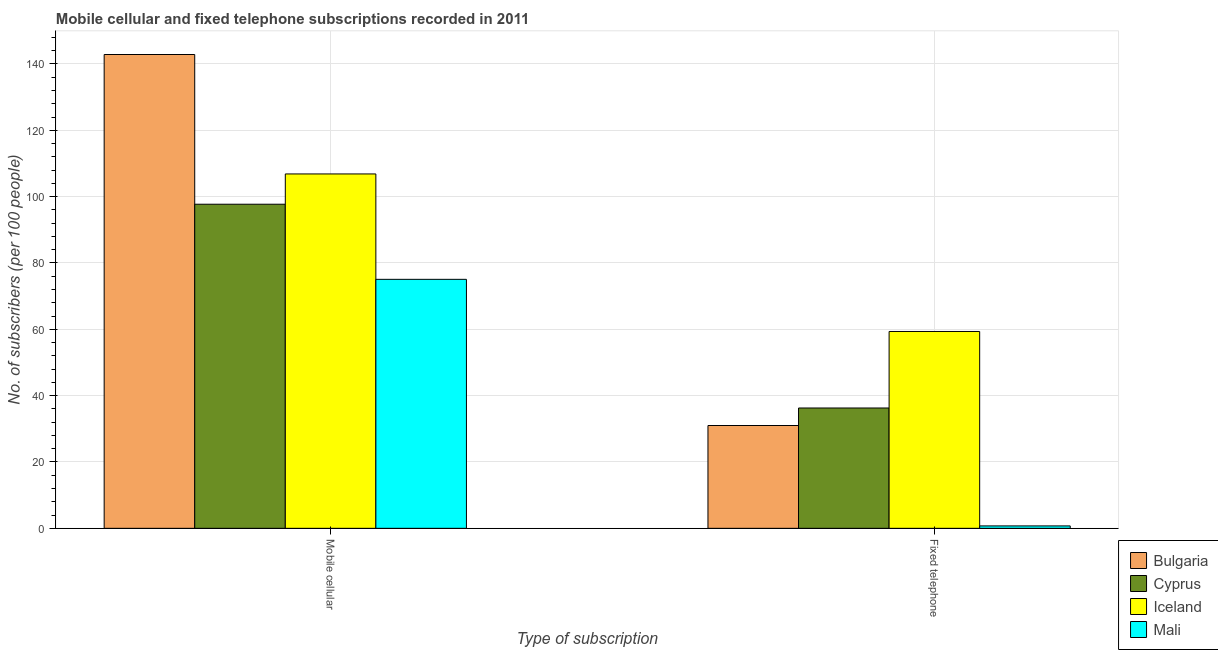How many different coloured bars are there?
Your answer should be very brief. 4. Are the number of bars per tick equal to the number of legend labels?
Give a very brief answer. Yes. How many bars are there on the 2nd tick from the left?
Make the answer very short. 4. What is the label of the 2nd group of bars from the left?
Provide a short and direct response. Fixed telephone. What is the number of mobile cellular subscribers in Bulgaria?
Make the answer very short. 142.85. Across all countries, what is the maximum number of mobile cellular subscribers?
Keep it short and to the point. 142.85. Across all countries, what is the minimum number of fixed telephone subscribers?
Your answer should be very brief. 0.73. In which country was the number of mobile cellular subscribers minimum?
Keep it short and to the point. Mali. What is the total number of fixed telephone subscribers in the graph?
Your response must be concise. 127.34. What is the difference between the number of mobile cellular subscribers in Iceland and that in Cyprus?
Make the answer very short. 9.13. What is the difference between the number of fixed telephone subscribers in Mali and the number of mobile cellular subscribers in Cyprus?
Provide a short and direct response. -96.98. What is the average number of fixed telephone subscribers per country?
Give a very brief answer. 31.83. What is the difference between the number of fixed telephone subscribers and number of mobile cellular subscribers in Iceland?
Your answer should be compact. -47.5. In how many countries, is the number of mobile cellular subscribers greater than 112 ?
Offer a terse response. 1. What is the ratio of the number of mobile cellular subscribers in Cyprus to that in Iceland?
Your answer should be very brief. 0.91. What does the 3rd bar from the right in Mobile cellular represents?
Offer a terse response. Cyprus. How many bars are there?
Provide a succinct answer. 8. How many countries are there in the graph?
Provide a succinct answer. 4. Are the values on the major ticks of Y-axis written in scientific E-notation?
Provide a short and direct response. No. Does the graph contain any zero values?
Offer a very short reply. No. Does the graph contain grids?
Give a very brief answer. Yes. Where does the legend appear in the graph?
Ensure brevity in your answer.  Bottom right. How many legend labels are there?
Ensure brevity in your answer.  4. How are the legend labels stacked?
Offer a very short reply. Vertical. What is the title of the graph?
Offer a very short reply. Mobile cellular and fixed telephone subscriptions recorded in 2011. What is the label or title of the X-axis?
Offer a very short reply. Type of subscription. What is the label or title of the Y-axis?
Ensure brevity in your answer.  No. of subscribers (per 100 people). What is the No. of subscribers (per 100 people) of Bulgaria in Mobile cellular?
Your answer should be compact. 142.85. What is the No. of subscribers (per 100 people) in Cyprus in Mobile cellular?
Give a very brief answer. 97.71. What is the No. of subscribers (per 100 people) of Iceland in Mobile cellular?
Give a very brief answer. 106.84. What is the No. of subscribers (per 100 people) of Mali in Mobile cellular?
Ensure brevity in your answer.  75.07. What is the No. of subscribers (per 100 people) in Bulgaria in Fixed telephone?
Your response must be concise. 30.99. What is the No. of subscribers (per 100 people) in Cyprus in Fixed telephone?
Your answer should be very brief. 36.28. What is the No. of subscribers (per 100 people) of Iceland in Fixed telephone?
Give a very brief answer. 59.34. What is the No. of subscribers (per 100 people) in Mali in Fixed telephone?
Keep it short and to the point. 0.73. Across all Type of subscription, what is the maximum No. of subscribers (per 100 people) in Bulgaria?
Your answer should be compact. 142.85. Across all Type of subscription, what is the maximum No. of subscribers (per 100 people) of Cyprus?
Your response must be concise. 97.71. Across all Type of subscription, what is the maximum No. of subscribers (per 100 people) in Iceland?
Your response must be concise. 106.84. Across all Type of subscription, what is the maximum No. of subscribers (per 100 people) of Mali?
Give a very brief answer. 75.07. Across all Type of subscription, what is the minimum No. of subscribers (per 100 people) in Bulgaria?
Provide a short and direct response. 30.99. Across all Type of subscription, what is the minimum No. of subscribers (per 100 people) in Cyprus?
Your response must be concise. 36.28. Across all Type of subscription, what is the minimum No. of subscribers (per 100 people) in Iceland?
Ensure brevity in your answer.  59.34. Across all Type of subscription, what is the minimum No. of subscribers (per 100 people) in Mali?
Your response must be concise. 0.73. What is the total No. of subscribers (per 100 people) of Bulgaria in the graph?
Provide a succinct answer. 173.84. What is the total No. of subscribers (per 100 people) in Cyprus in the graph?
Ensure brevity in your answer.  133.99. What is the total No. of subscribers (per 100 people) in Iceland in the graph?
Keep it short and to the point. 166.19. What is the total No. of subscribers (per 100 people) in Mali in the graph?
Your answer should be compact. 75.79. What is the difference between the No. of subscribers (per 100 people) of Bulgaria in Mobile cellular and that in Fixed telephone?
Keep it short and to the point. 111.85. What is the difference between the No. of subscribers (per 100 people) of Cyprus in Mobile cellular and that in Fixed telephone?
Offer a very short reply. 61.43. What is the difference between the No. of subscribers (per 100 people) of Iceland in Mobile cellular and that in Fixed telephone?
Ensure brevity in your answer.  47.5. What is the difference between the No. of subscribers (per 100 people) in Mali in Mobile cellular and that in Fixed telephone?
Offer a very short reply. 74.34. What is the difference between the No. of subscribers (per 100 people) in Bulgaria in Mobile cellular and the No. of subscribers (per 100 people) in Cyprus in Fixed telephone?
Offer a very short reply. 106.57. What is the difference between the No. of subscribers (per 100 people) in Bulgaria in Mobile cellular and the No. of subscribers (per 100 people) in Iceland in Fixed telephone?
Your answer should be very brief. 83.5. What is the difference between the No. of subscribers (per 100 people) in Bulgaria in Mobile cellular and the No. of subscribers (per 100 people) in Mali in Fixed telephone?
Provide a succinct answer. 142.12. What is the difference between the No. of subscribers (per 100 people) in Cyprus in Mobile cellular and the No. of subscribers (per 100 people) in Iceland in Fixed telephone?
Provide a short and direct response. 38.37. What is the difference between the No. of subscribers (per 100 people) in Cyprus in Mobile cellular and the No. of subscribers (per 100 people) in Mali in Fixed telephone?
Your answer should be compact. 96.98. What is the difference between the No. of subscribers (per 100 people) in Iceland in Mobile cellular and the No. of subscribers (per 100 people) in Mali in Fixed telephone?
Keep it short and to the point. 106.12. What is the average No. of subscribers (per 100 people) of Bulgaria per Type of subscription?
Provide a succinct answer. 86.92. What is the average No. of subscribers (per 100 people) of Cyprus per Type of subscription?
Keep it short and to the point. 66.99. What is the average No. of subscribers (per 100 people) in Iceland per Type of subscription?
Provide a succinct answer. 83.09. What is the average No. of subscribers (per 100 people) of Mali per Type of subscription?
Ensure brevity in your answer.  37.9. What is the difference between the No. of subscribers (per 100 people) in Bulgaria and No. of subscribers (per 100 people) in Cyprus in Mobile cellular?
Ensure brevity in your answer.  45.14. What is the difference between the No. of subscribers (per 100 people) of Bulgaria and No. of subscribers (per 100 people) of Iceland in Mobile cellular?
Offer a terse response. 36. What is the difference between the No. of subscribers (per 100 people) in Bulgaria and No. of subscribers (per 100 people) in Mali in Mobile cellular?
Give a very brief answer. 67.78. What is the difference between the No. of subscribers (per 100 people) in Cyprus and No. of subscribers (per 100 people) in Iceland in Mobile cellular?
Make the answer very short. -9.13. What is the difference between the No. of subscribers (per 100 people) of Cyprus and No. of subscribers (per 100 people) of Mali in Mobile cellular?
Your response must be concise. 22.64. What is the difference between the No. of subscribers (per 100 people) in Iceland and No. of subscribers (per 100 people) in Mali in Mobile cellular?
Your answer should be compact. 31.78. What is the difference between the No. of subscribers (per 100 people) in Bulgaria and No. of subscribers (per 100 people) in Cyprus in Fixed telephone?
Provide a succinct answer. -5.28. What is the difference between the No. of subscribers (per 100 people) in Bulgaria and No. of subscribers (per 100 people) in Iceland in Fixed telephone?
Your response must be concise. -28.35. What is the difference between the No. of subscribers (per 100 people) in Bulgaria and No. of subscribers (per 100 people) in Mali in Fixed telephone?
Provide a short and direct response. 30.27. What is the difference between the No. of subscribers (per 100 people) in Cyprus and No. of subscribers (per 100 people) in Iceland in Fixed telephone?
Provide a short and direct response. -23.07. What is the difference between the No. of subscribers (per 100 people) of Cyprus and No. of subscribers (per 100 people) of Mali in Fixed telephone?
Ensure brevity in your answer.  35.55. What is the difference between the No. of subscribers (per 100 people) in Iceland and No. of subscribers (per 100 people) in Mali in Fixed telephone?
Give a very brief answer. 58.62. What is the ratio of the No. of subscribers (per 100 people) in Bulgaria in Mobile cellular to that in Fixed telephone?
Ensure brevity in your answer.  4.61. What is the ratio of the No. of subscribers (per 100 people) of Cyprus in Mobile cellular to that in Fixed telephone?
Ensure brevity in your answer.  2.69. What is the ratio of the No. of subscribers (per 100 people) in Iceland in Mobile cellular to that in Fixed telephone?
Provide a short and direct response. 1.8. What is the ratio of the No. of subscribers (per 100 people) of Mali in Mobile cellular to that in Fixed telephone?
Keep it short and to the point. 103.37. What is the difference between the highest and the second highest No. of subscribers (per 100 people) of Bulgaria?
Offer a terse response. 111.85. What is the difference between the highest and the second highest No. of subscribers (per 100 people) in Cyprus?
Provide a short and direct response. 61.43. What is the difference between the highest and the second highest No. of subscribers (per 100 people) in Iceland?
Provide a short and direct response. 47.5. What is the difference between the highest and the second highest No. of subscribers (per 100 people) in Mali?
Your response must be concise. 74.34. What is the difference between the highest and the lowest No. of subscribers (per 100 people) in Bulgaria?
Your response must be concise. 111.85. What is the difference between the highest and the lowest No. of subscribers (per 100 people) in Cyprus?
Your response must be concise. 61.43. What is the difference between the highest and the lowest No. of subscribers (per 100 people) of Iceland?
Provide a succinct answer. 47.5. What is the difference between the highest and the lowest No. of subscribers (per 100 people) of Mali?
Give a very brief answer. 74.34. 